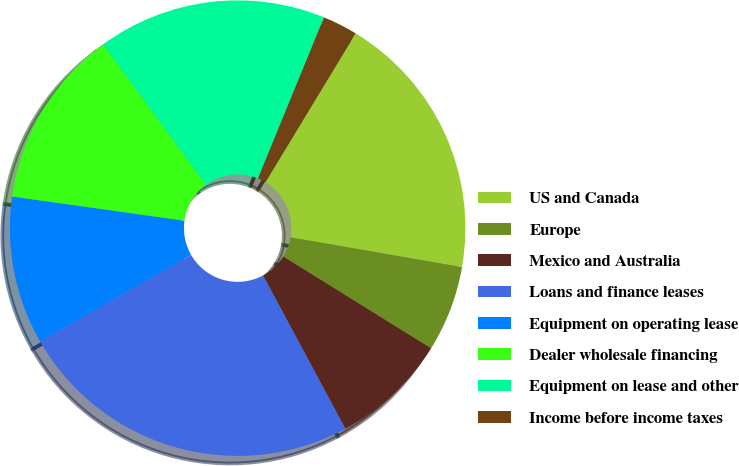Convert chart. <chart><loc_0><loc_0><loc_500><loc_500><pie_chart><fcel>US and Canada<fcel>Europe<fcel>Mexico and Australia<fcel>Loans and finance leases<fcel>Equipment on operating lease<fcel>Dealer wholesale financing<fcel>Equipment on lease and other<fcel>Income before income taxes<nl><fcel>19.07%<fcel>6.11%<fcel>8.31%<fcel>24.54%<fcel>10.52%<fcel>12.72%<fcel>16.25%<fcel>2.48%<nl></chart> 